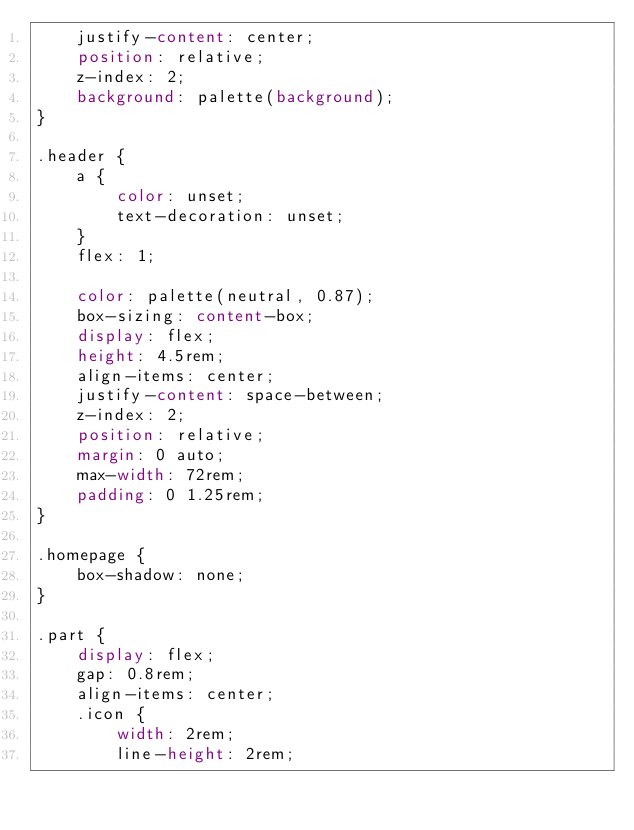<code> <loc_0><loc_0><loc_500><loc_500><_CSS_>    justify-content: center;
    position: relative;
    z-index: 2;
    background: palette(background);
}

.header {
    a {
        color: unset;
        text-decoration: unset;
    }
    flex: 1;

    color: palette(neutral, 0.87);
    box-sizing: content-box;
    display: flex;
    height: 4.5rem;
    align-items: center;
    justify-content: space-between;
    z-index: 2;
    position: relative;
    margin: 0 auto;
    max-width: 72rem;
    padding: 0 1.25rem;
}

.homepage {
    box-shadow: none;
}

.part {
    display: flex;
    gap: 0.8rem;
    align-items: center;
    .icon {
        width: 2rem;
        line-height: 2rem;</code> 